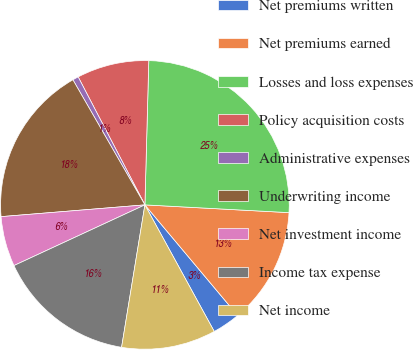<chart> <loc_0><loc_0><loc_500><loc_500><pie_chart><fcel>Net premiums written<fcel>Net premiums earned<fcel>Losses and loss expenses<fcel>Policy acquisition costs<fcel>Administrative expenses<fcel>Underwriting income<fcel>Net investment income<fcel>Income tax expense<fcel>Net income<nl><fcel>3.13%<fcel>13.04%<fcel>25.43%<fcel>8.08%<fcel>0.66%<fcel>17.99%<fcel>5.61%<fcel>15.51%<fcel>10.56%<nl></chart> 